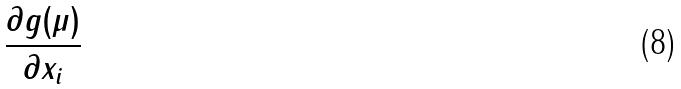<formula> <loc_0><loc_0><loc_500><loc_500>\frac { \partial g ( \mu ) } { \partial x _ { i } }</formula> 